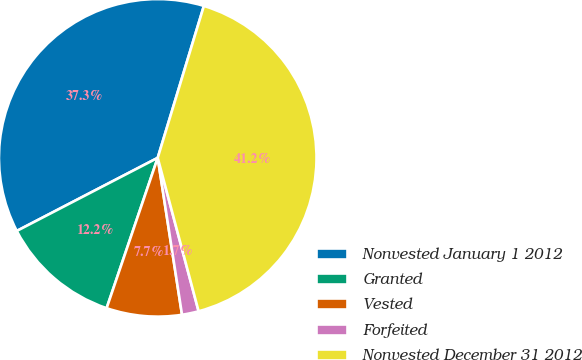<chart> <loc_0><loc_0><loc_500><loc_500><pie_chart><fcel>Nonvested January 1 2012<fcel>Granted<fcel>Vested<fcel>Forfeited<fcel>Nonvested December 31 2012<nl><fcel>37.31%<fcel>12.17%<fcel>7.66%<fcel>1.7%<fcel>41.16%<nl></chart> 